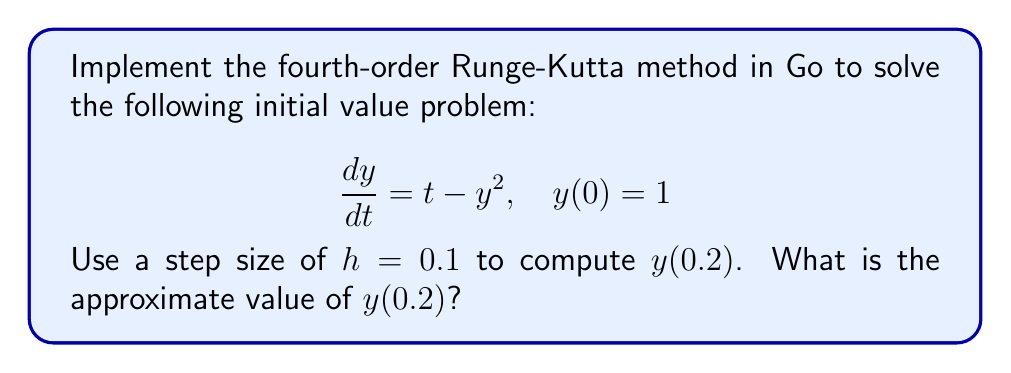What is the answer to this math problem? Let's implement the fourth-order Runge-Kutta method in Go to solve this problem:

1. Define the ODE function:
   $$f(t, y) = t - y^2$$

2. Initialize variables:
   $t_0 = 0$, $y_0 = 1$, $h = 0.1$, $t_target = 0.2$

3. Implement the Runge-Kutta method:

   For each step:
   $$k_1 = h \cdot f(t_n, y_n)$$
   $$k_2 = h \cdot f(t_n + \frac{h}{2}, y_n + \frac{k_1}{2})$$
   $$k_3 = h \cdot f(t_n + \frac{h}{2}, y_n + \frac{k_2}{2})$$
   $$k_4 = h \cdot f(t_n + h, y_n + k_3)$$
   $$y_{n+1} = y_n + \frac{1}{6}(k_1 + 2k_2 + 2k_3 + k_4)$$

4. In Go, the implementation might look like this:

   ```go
   package main

   import (
       "fmt"
       "math"
   )

   func f(t, y float64) float64 {
       return t - math.Pow(y, 2)
   }

   func rungeKutta4(t0, y0, h, tTarget float64) float64 {
       t, y := t0, y0
       for t < tTarget {
           k1 := h * f(t, y)
           k2 := h * f(t+h/2, y+k1/2)
           k3 := h * f(t+h/2, y+k2/2)
           k4 := h * f(t+h, y+k3)
           y += (k1 + 2*k2 + 2*k3 + k4) / 6
           t += h
       }
       return y
   }

   func main() {
       result := rungeKutta4(0, 1, 0.1, 0.2)
       fmt.Printf("y(0.2) ≈ %.6f\n", result)
   }
   ```

5. Running this code will give us the approximate value of $y(0.2)$.

The Runge-Kutta method performs two steps to reach $t = 0.2$, providing a more accurate approximation compared to simpler methods like Euler's method.
Answer: $y(0.2) \approx 0.784403$ 